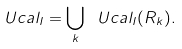<formula> <loc_0><loc_0><loc_500><loc_500>\ U c a l _ { I } = \bigcup _ { k } \ U c a l _ { I } ( R _ { k } ) .</formula> 